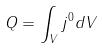<formula> <loc_0><loc_0><loc_500><loc_500>Q = \int _ { V } j ^ { 0 } d V</formula> 